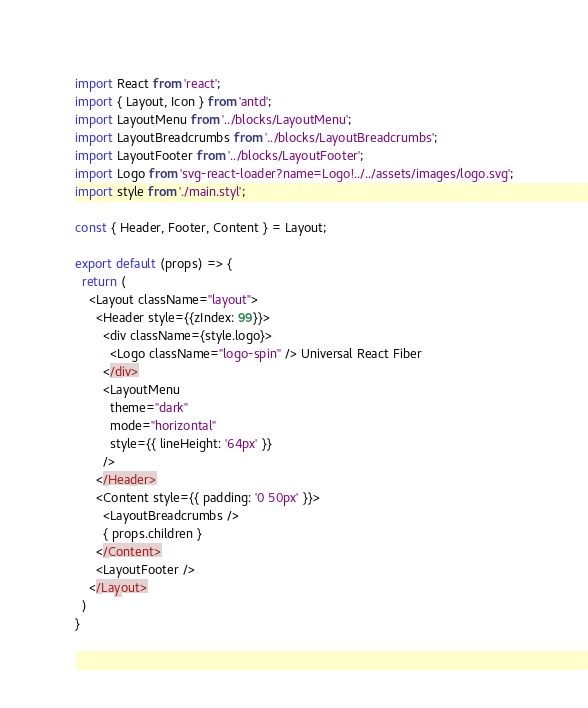Convert code to text. <code><loc_0><loc_0><loc_500><loc_500><_JavaScript_>import React from 'react';
import { Layout, Icon } from 'antd';
import LayoutMenu from '../blocks/LayoutMenu';
import LayoutBreadcrumbs from '../blocks/LayoutBreadcrumbs';
import LayoutFooter from '../blocks/LayoutFooter';
import Logo from 'svg-react-loader?name=Logo!../../assets/images/logo.svg';
import style from './main.styl';

const { Header, Footer, Content } = Layout;

export default (props) => {
  return (
    <Layout className="layout">
      <Header style={{zIndex: 99}}>
        <div className={style.logo}>
          <Logo className="logo-spin" /> Universal React Fiber
        </div>
        <LayoutMenu
          theme="dark"
          mode="horizontal"
          style={{ lineHeight: '64px' }}
        />
      </Header>
      <Content style={{ padding: '0 50px' }}>
        <LayoutBreadcrumbs />
        { props.children }
      </Content>
      <LayoutFooter />
    </Layout>
  )
}
</code> 